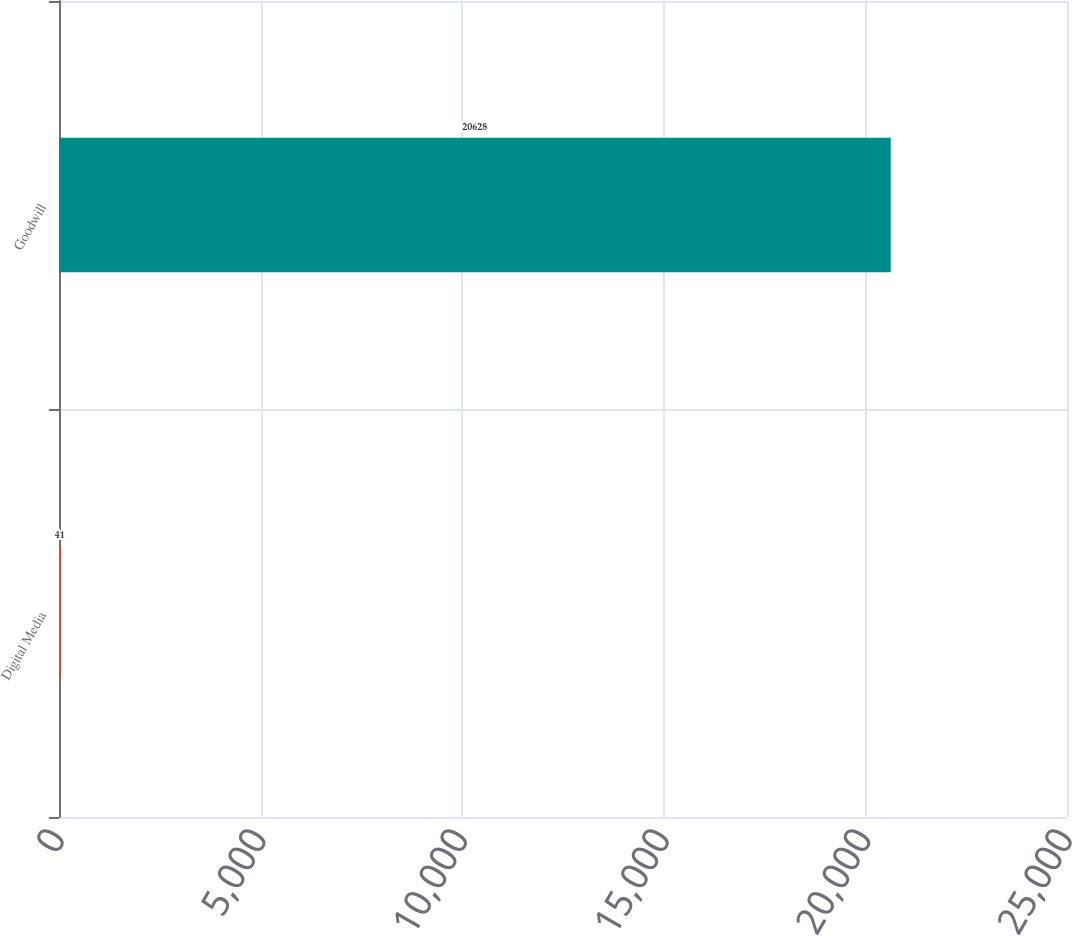Convert chart to OTSL. <chart><loc_0><loc_0><loc_500><loc_500><bar_chart><fcel>Digital Media<fcel>Goodwill<nl><fcel>41<fcel>20628<nl></chart> 